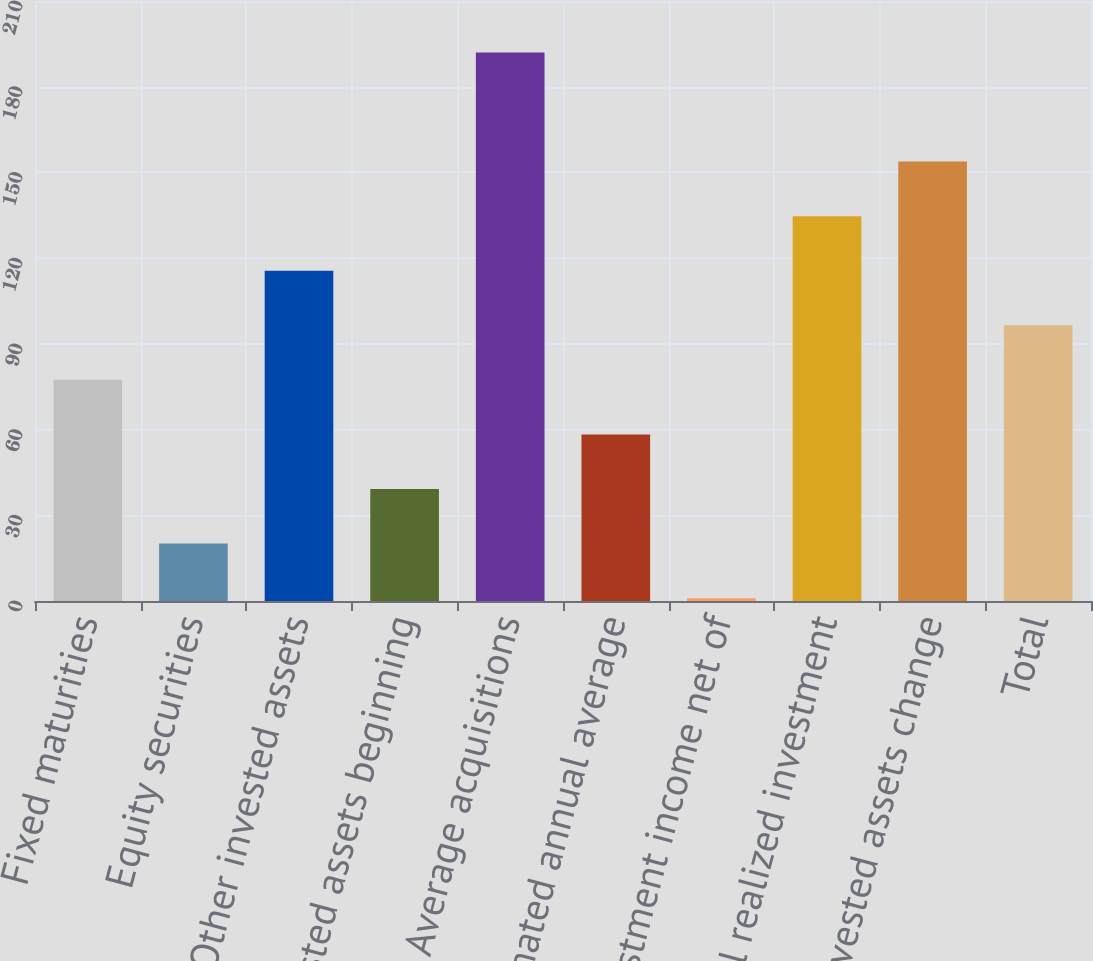Convert chart to OTSL. <chart><loc_0><loc_0><loc_500><loc_500><bar_chart><fcel>Fixed maturities<fcel>Equity securities<fcel>Other invested assets<fcel>Invested assets beginning<fcel>Average acquisitions<fcel>Estimated annual average<fcel>Total investment income net of<fcel>Total realized investment<fcel>Total invested assets change<fcel>Total<nl><fcel>77.4<fcel>20.1<fcel>115.6<fcel>39.2<fcel>192<fcel>58.3<fcel>1<fcel>134.7<fcel>153.8<fcel>96.5<nl></chart> 